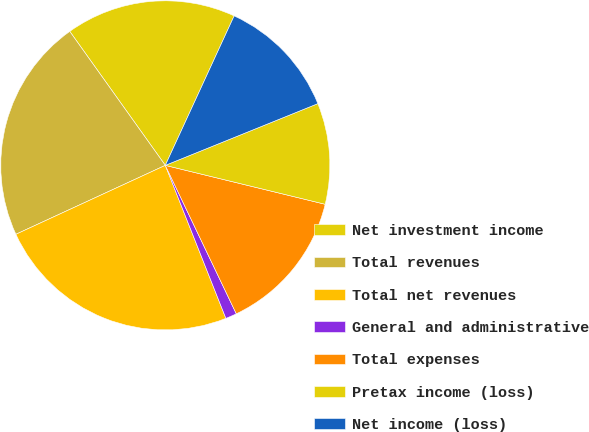<chart> <loc_0><loc_0><loc_500><loc_500><pie_chart><fcel>Net investment income<fcel>Total revenues<fcel>Total net revenues<fcel>General and administrative<fcel>Total expenses<fcel>Pretax income (loss)<fcel>Net income (loss)<nl><fcel>16.73%<fcel>22.02%<fcel>24.12%<fcel>1.1%<fcel>14.1%<fcel>9.92%<fcel>12.01%<nl></chart> 